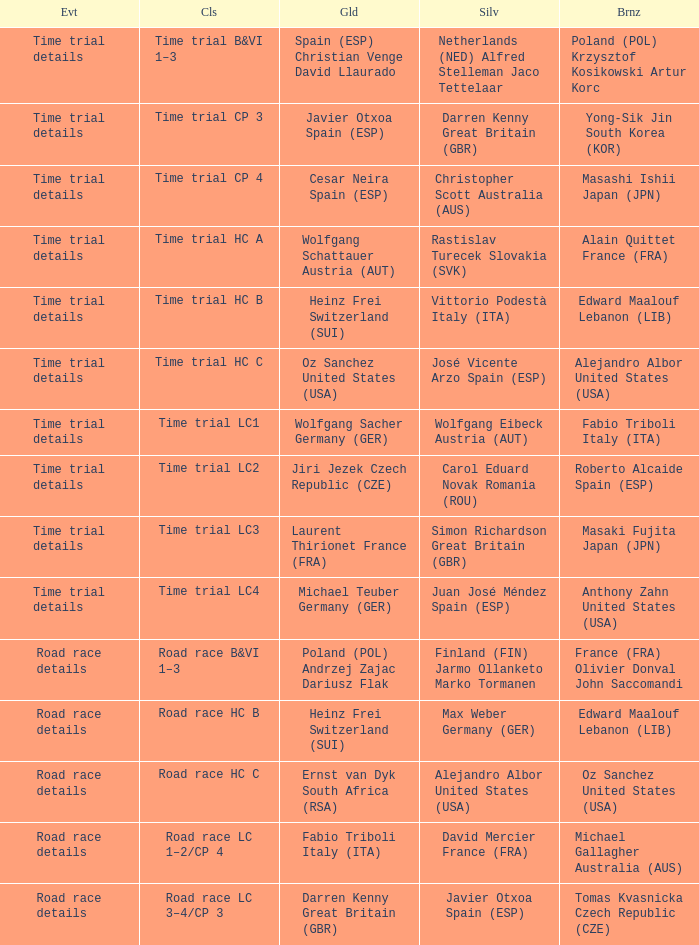What is the event when gold is darren kenny great britain (gbr)? Road race details. 